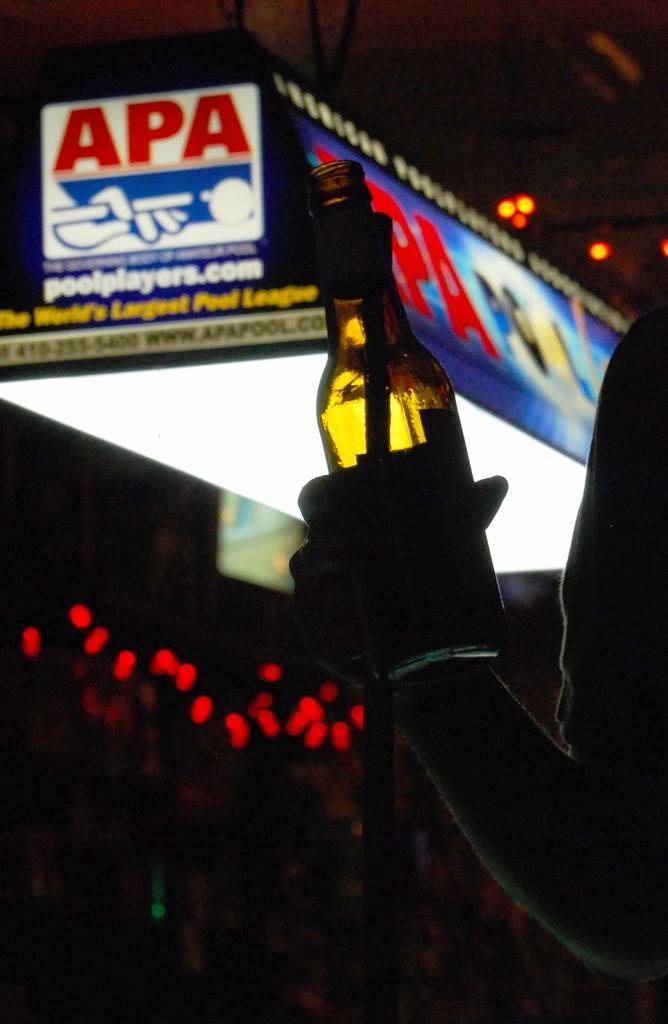<image>
Create a compact narrative representing the image presented. A light up billboard for the APA Pool Players League ahngs above a bar. 